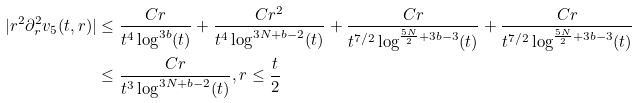<formula> <loc_0><loc_0><loc_500><loc_500>| r ^ { 2 } \partial _ { r } ^ { 2 } v _ { 5 } ( t , r ) | & \leq \frac { C r } { t ^ { 4 } \log ^ { 3 b } ( t ) } + \frac { C r ^ { 2 } } { t ^ { 4 } \log ^ { 3 N + b - 2 } ( t ) } + \frac { C r } { t ^ { 7 / 2 } \log ^ { \frac { 5 N } { 2 } + 3 b - 3 } ( t ) } + \frac { C r } { t ^ { 7 / 2 } \log ^ { \frac { 5 N } { 2 } + 3 b - 3 } ( t ) } \\ & \leq \frac { C r } { t ^ { 3 } \log ^ { 3 N + b - 2 } ( t ) } , r \leq \frac { t } { 2 }</formula> 